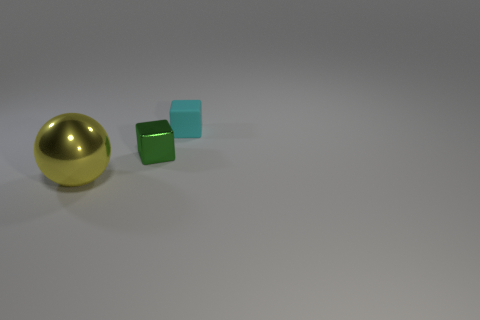Is there any other thing that is the same size as the yellow sphere?
Provide a short and direct response. No. Is the shape of the tiny green thing the same as the small matte thing?
Make the answer very short. Yes. What number of other objects are the same size as the yellow ball?
Provide a short and direct response. 0. What number of things are either things behind the ball or objects that are right of the big yellow metal ball?
Your answer should be very brief. 2. What number of other objects are the same shape as the green object?
Offer a very short reply. 1. There is a ball; how many cyan objects are behind it?
Offer a terse response. 1. How many small gray shiny things are there?
Ensure brevity in your answer.  0. Is the green block the same size as the cyan rubber thing?
Your response must be concise. Yes. There is a metal thing that is right of the shiny object in front of the green block; are there any big metal spheres left of it?
Make the answer very short. Yes. What material is the other small object that is the same shape as the green shiny thing?
Ensure brevity in your answer.  Rubber. 